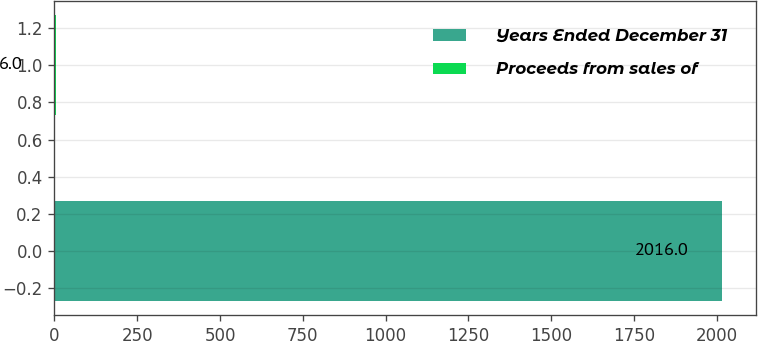<chart> <loc_0><loc_0><loc_500><loc_500><bar_chart><fcel>Years Ended December 31<fcel>Proceeds from sales of<nl><fcel>2016<fcel>6<nl></chart> 